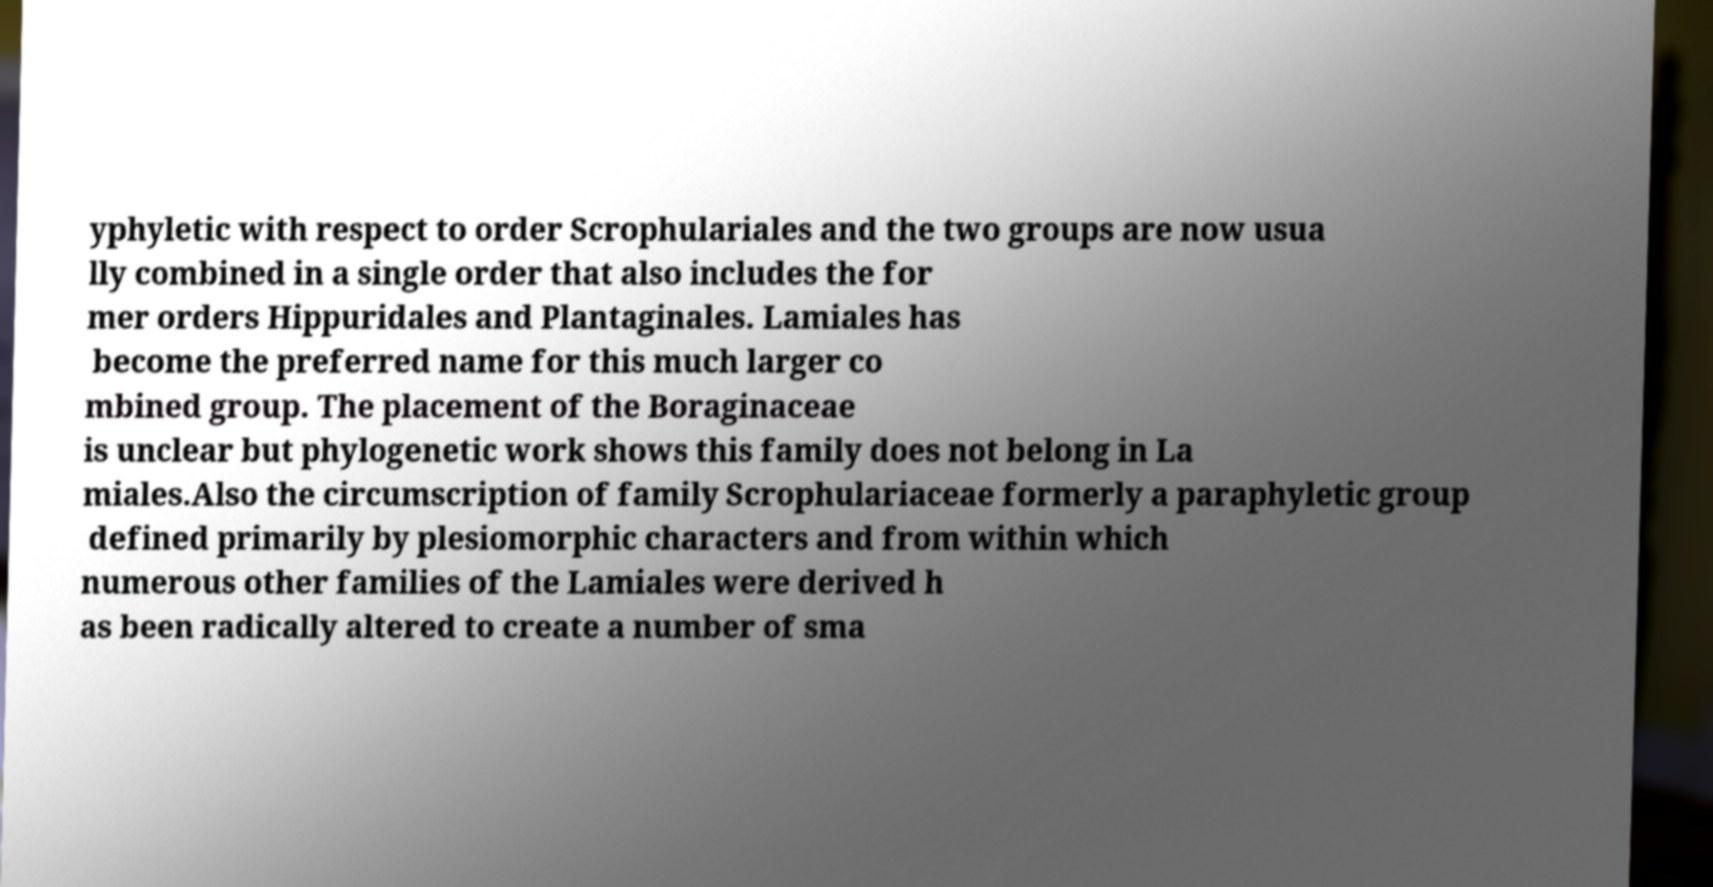I need the written content from this picture converted into text. Can you do that? yphyletic with respect to order Scrophulariales and the two groups are now usua lly combined in a single order that also includes the for mer orders Hippuridales and Plantaginales. Lamiales has become the preferred name for this much larger co mbined group. The placement of the Boraginaceae is unclear but phylogenetic work shows this family does not belong in La miales.Also the circumscription of family Scrophulariaceae formerly a paraphyletic group defined primarily by plesiomorphic characters and from within which numerous other families of the Lamiales were derived h as been radically altered to create a number of sma 